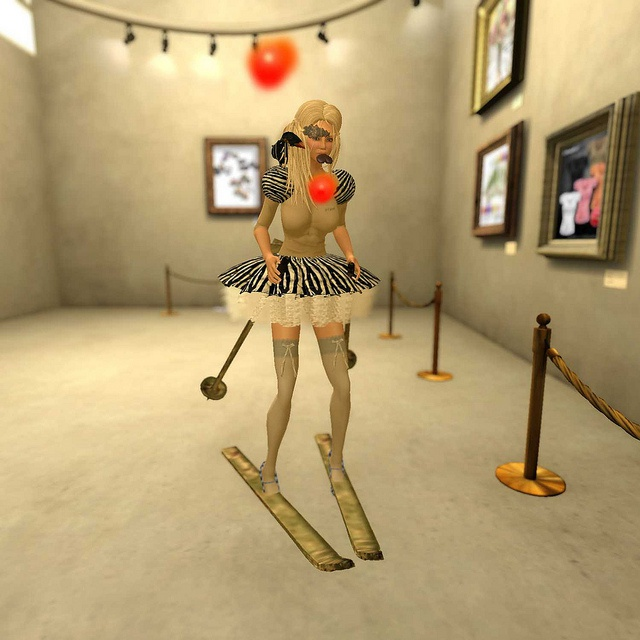Describe the objects in this image and their specific colors. I can see people in white, olive, tan, and black tones and skis in white, tan, and olive tones in this image. 